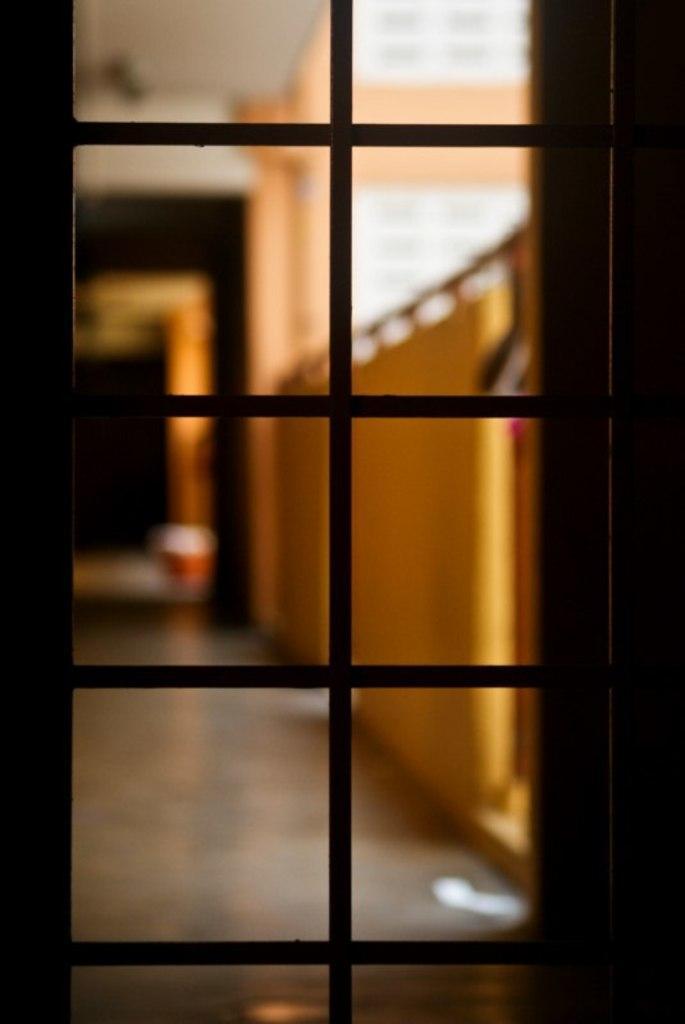How would you summarize this image in a sentence or two? This is an inside view. Here I can see a glass door. Behind the door, I can see the floor and the walls. The background is blurred. 